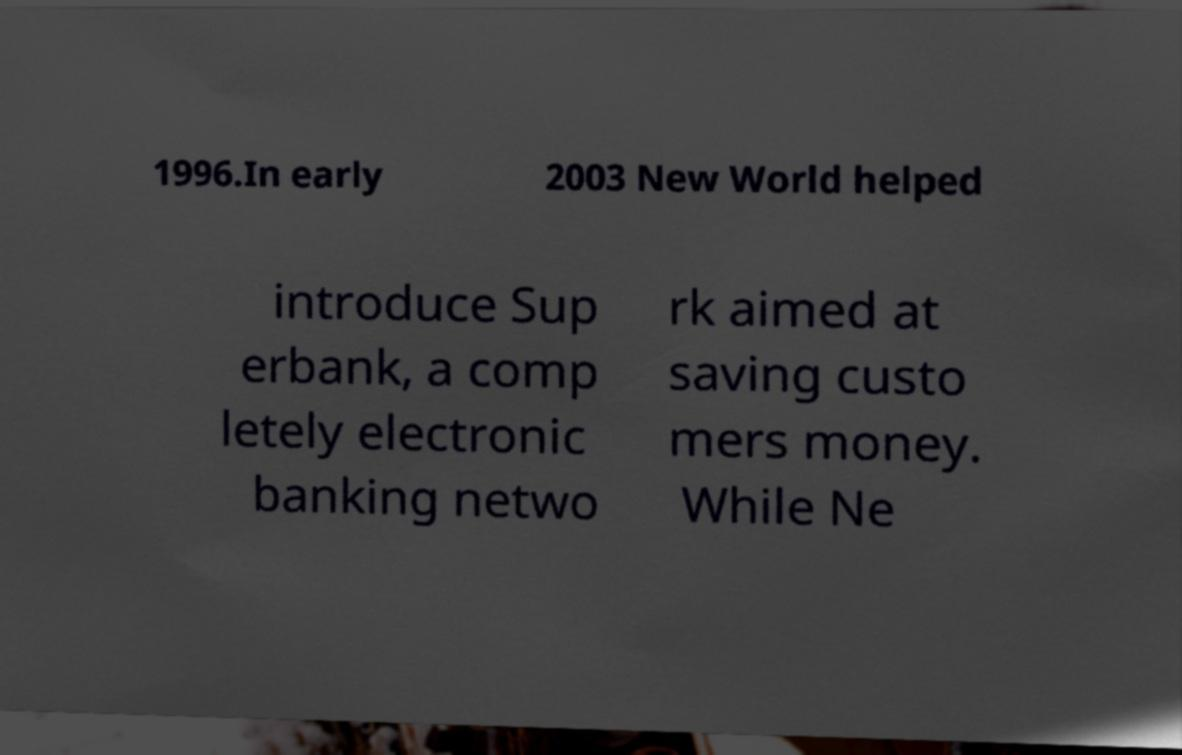Can you read and provide the text displayed in the image?This photo seems to have some interesting text. Can you extract and type it out for me? 1996.In early 2003 New World helped introduce Sup erbank, a comp letely electronic banking netwo rk aimed at saving custo mers money. While Ne 